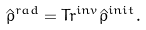<formula> <loc_0><loc_0><loc_500><loc_500>\hat { \rho } ^ { r a d } = T r ^ { i n v } \hat { \rho } ^ { i n i t } .</formula> 